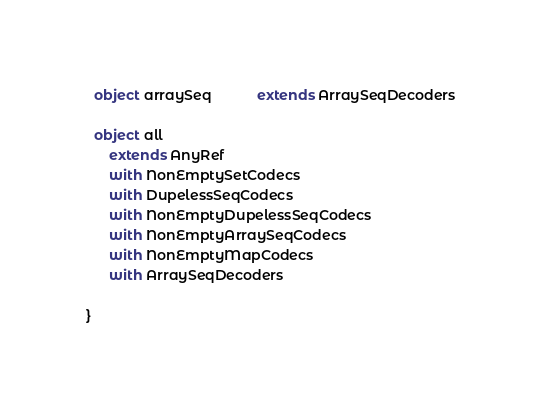<code> <loc_0><loc_0><loc_500><loc_500><_Scala_>  object arraySeq            extends ArraySeqDecoders

  object all
      extends AnyRef
      with NonEmptySetCodecs
      with DupelessSeqCodecs
      with NonEmptyDupelessSeqCodecs
      with NonEmptyArraySeqCodecs
      with NonEmptyMapCodecs
      with ArraySeqDecoders

}
</code> 